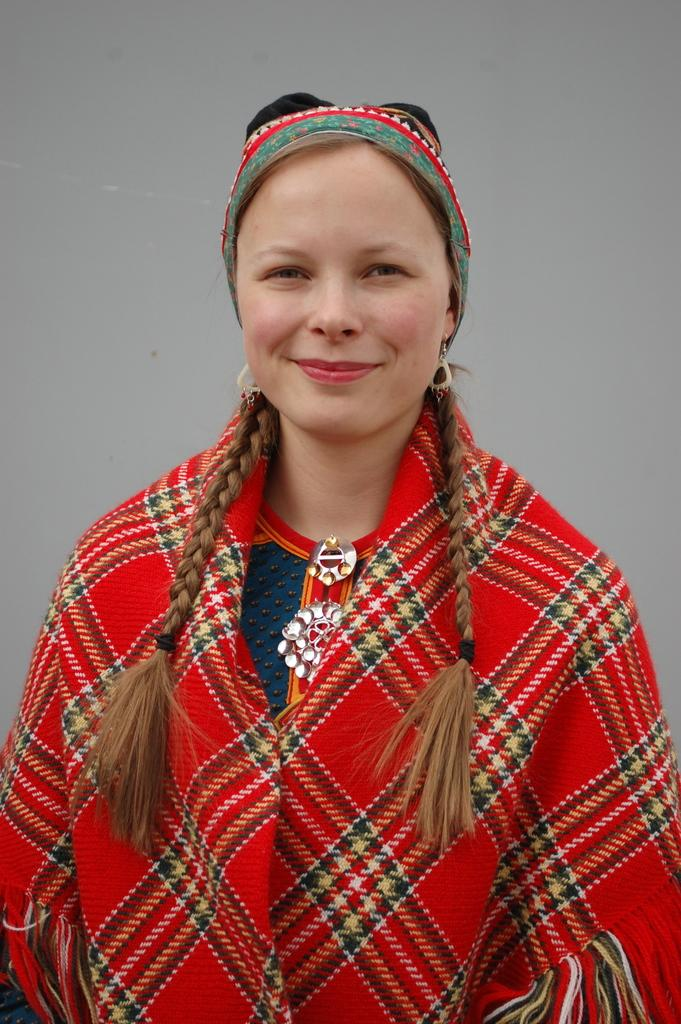Who or what is the main subject of the image? There is a person in the image. What can be seen in the background of the image? The background of the image is white. How many eggs are visible in the image? There are no eggs present in the image. Is the person in the image crying? The image does not provide any information about the person's emotional state, so it cannot be determined if they are crying. 